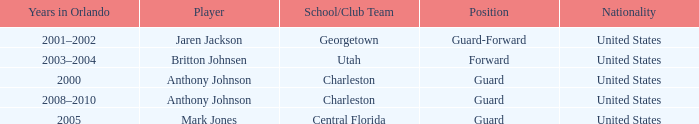Who was the player occupying the guard-forward spot? Jaren Jackson. 